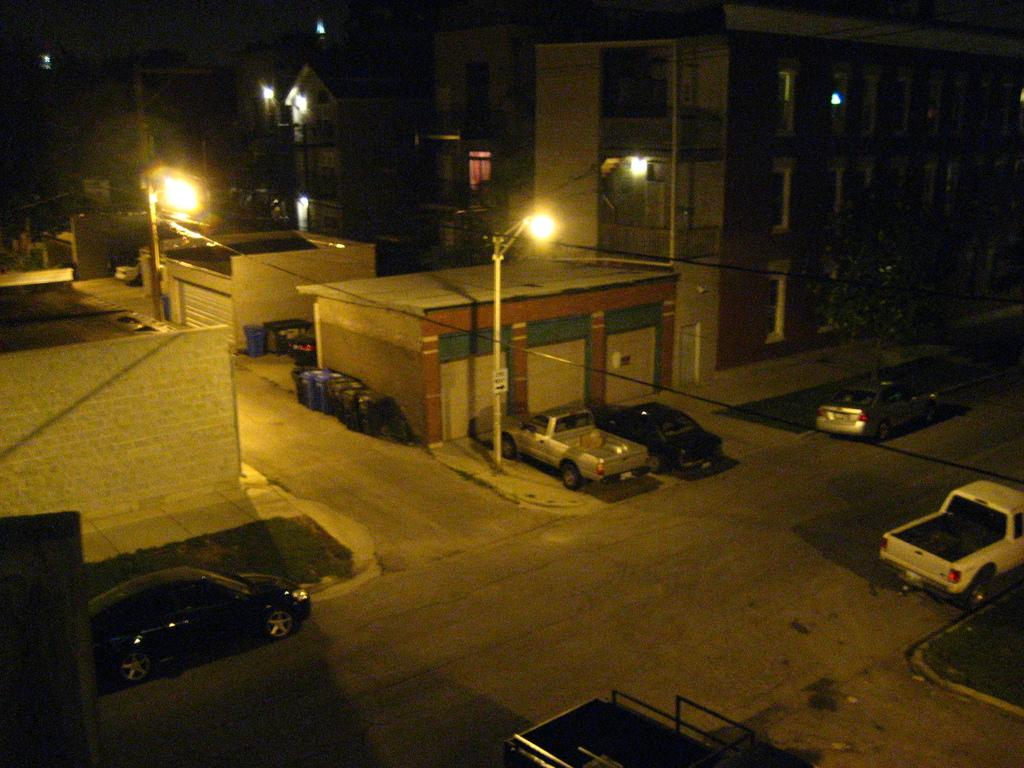What can be seen on the road in the image? There are cars parked on the road in the image. What structures are present in the image besides cars? There are electric poles and buildings in the image. How many clocks can be seen hanging on the buildings in the image? There are no clocks visible in the image. What type of animal can be seen playing with the cars in the image? There are no animals present in the image, let alone bears playing with the cars. 